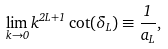<formula> <loc_0><loc_0><loc_500><loc_500>\lim _ { k \to 0 } k ^ { 2 L + 1 } \cot ( \delta _ { L } ) \equiv \frac { 1 } { a _ { L } } ,</formula> 